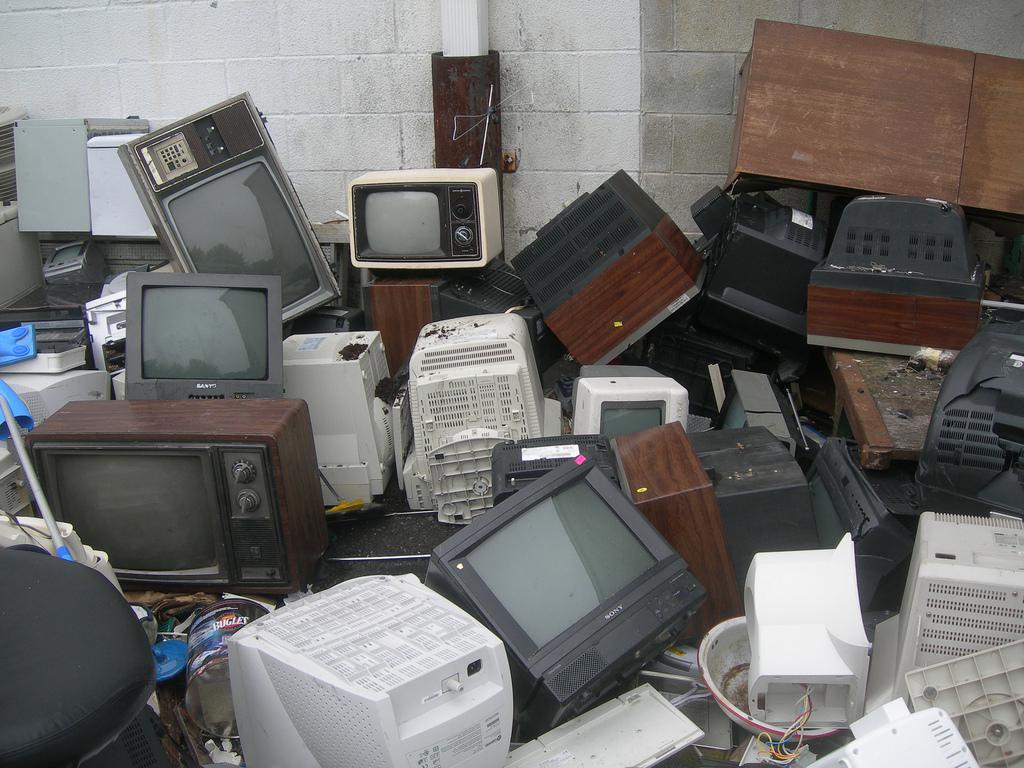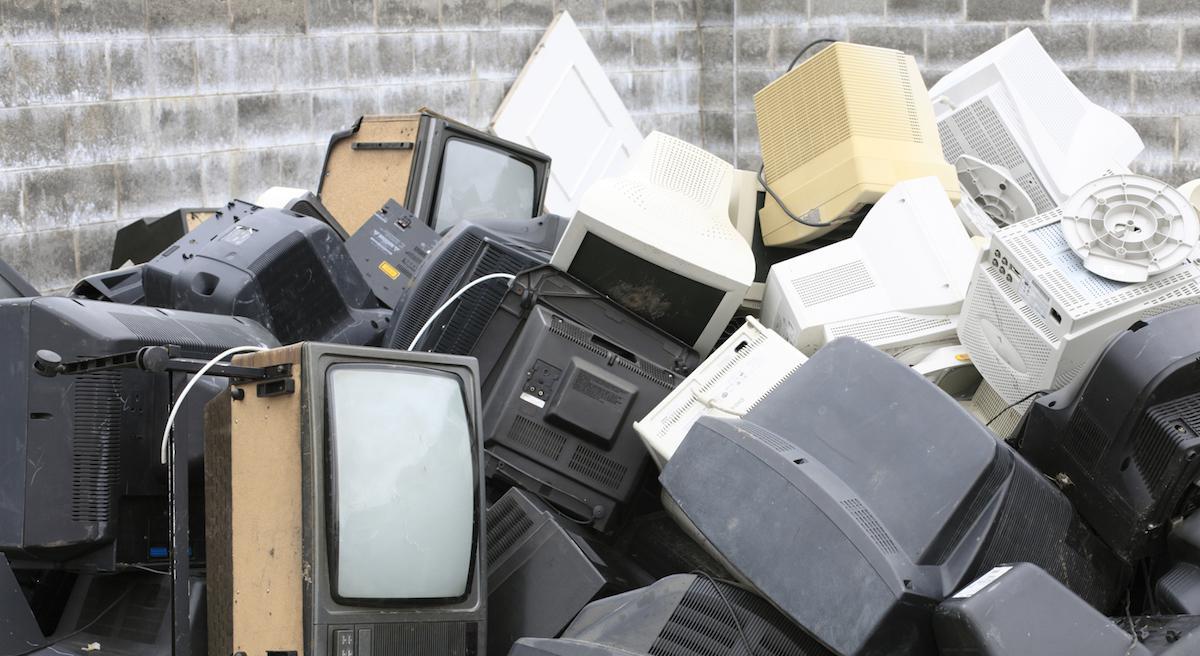The first image is the image on the left, the second image is the image on the right. Evaluate the accuracy of this statement regarding the images: "The televisions in each of the images are stacked up in piles.". Is it true? Answer yes or no. Yes. The first image is the image on the left, the second image is the image on the right. Assess this claim about the two images: "there is a pile of old tv's outside in front of a brick building". Correct or not? Answer yes or no. Yes. 